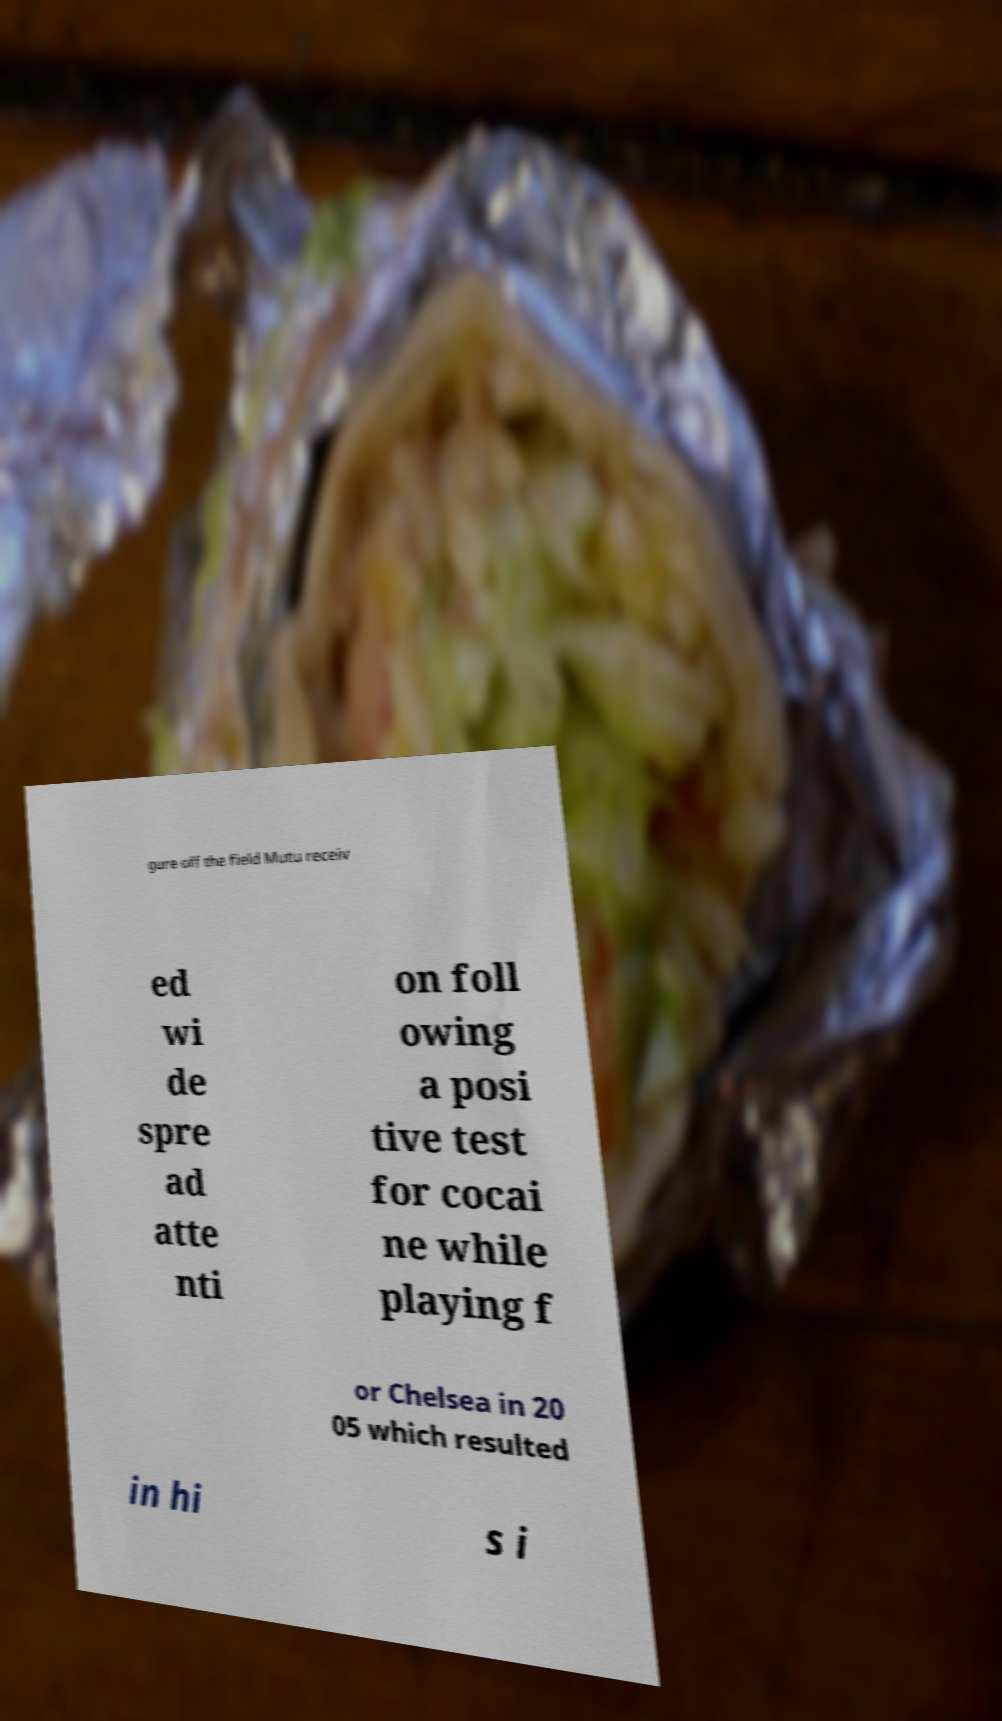Could you extract and type out the text from this image? gure off the field Mutu receiv ed wi de spre ad atte nti on foll owing a posi tive test for cocai ne while playing f or Chelsea in 20 05 which resulted in hi s i 